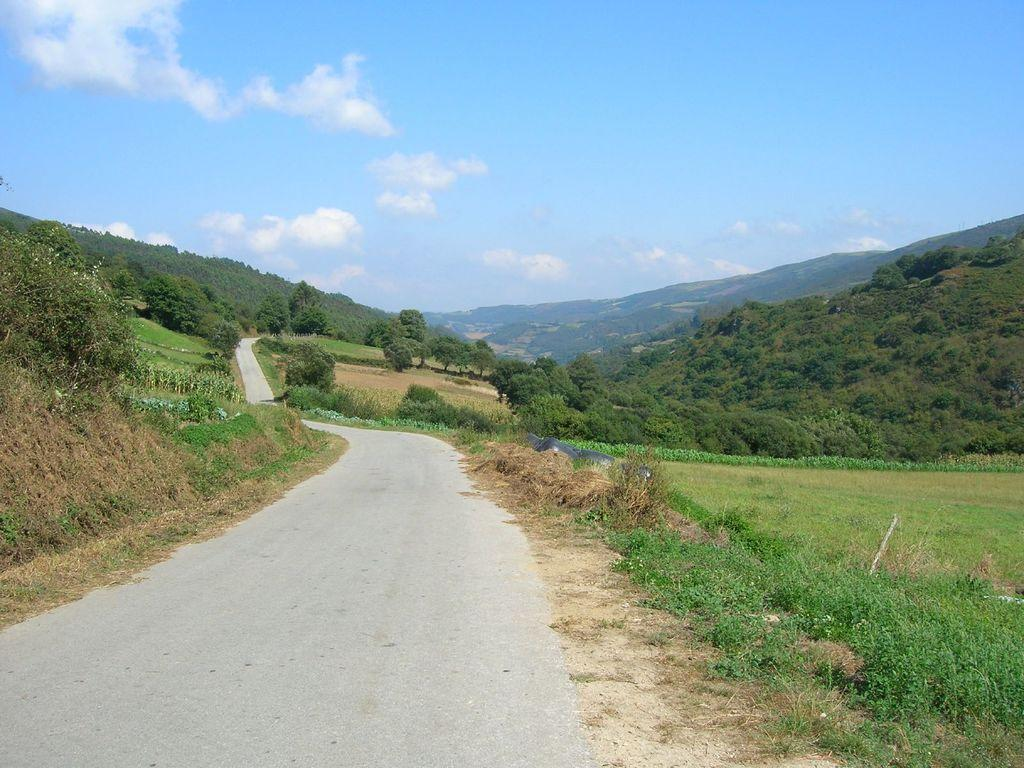What is located in the foreground of the image? There is a road in the foreground of the image. What can be seen in the background of the image? There is a group of trees and mountains visible in the background of the image. What is the condition of the sky in the image? The sky is cloudy in the background of the image. What type of dress is being copied in the image? There is no dress or copying activity present in the image. How comfortable are the mountains in the image? The mountains are not capable of feeling comfort, as they are inanimate objects. 